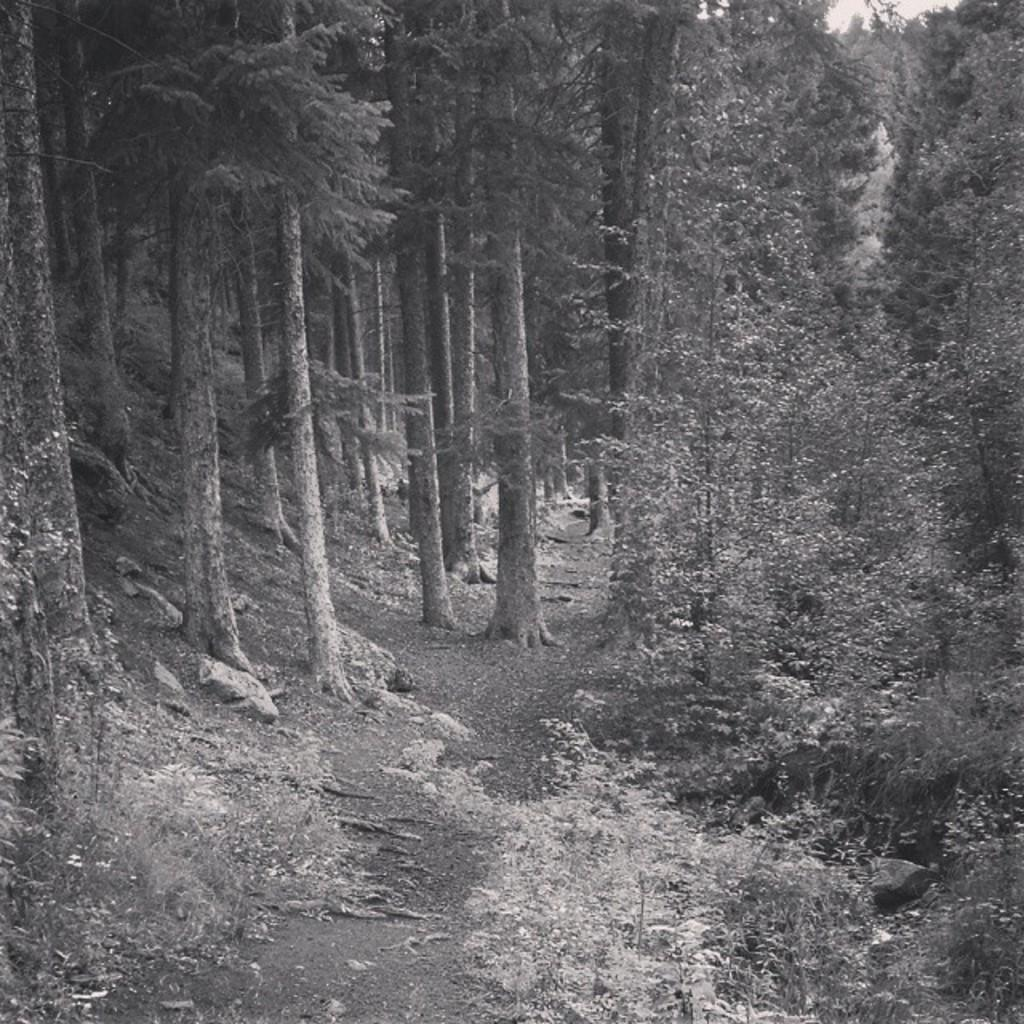What type of vegetation can be seen in the image? There are trees and plants in the image. What part of the natural environment is visible in the image? The sky is visible in the image. How many giraffes can be seen in the image? There are no giraffes present in the image. Is it raining in the image? There is no indication of rain in the image. 